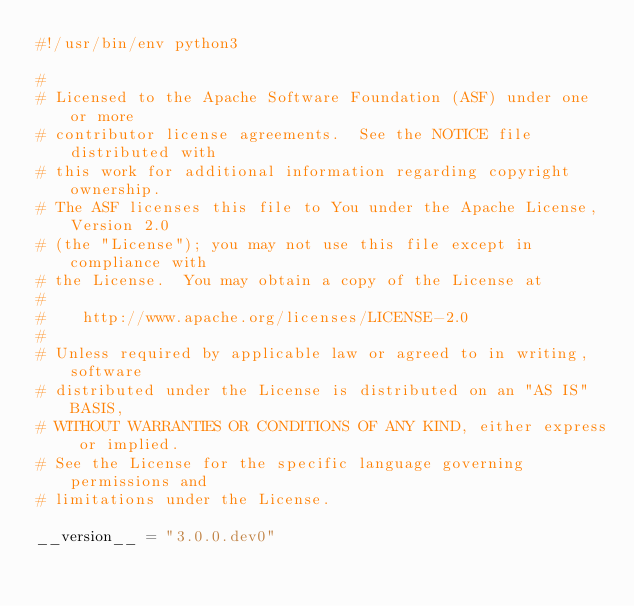<code> <loc_0><loc_0><loc_500><loc_500><_Python_>#!/usr/bin/env python3

#
# Licensed to the Apache Software Foundation (ASF) under one or more
# contributor license agreements.  See the NOTICE file distributed with
# this work for additional information regarding copyright ownership.
# The ASF licenses this file to You under the Apache License, Version 2.0
# (the "License"); you may not use this file except in compliance with
# the License.  You may obtain a copy of the License at
#
#    http://www.apache.org/licenses/LICENSE-2.0
#
# Unless required by applicable law or agreed to in writing, software
# distributed under the License is distributed on an "AS IS" BASIS,
# WITHOUT WARRANTIES OR CONDITIONS OF ANY KIND, either express or implied.
# See the License for the specific language governing permissions and
# limitations under the License.

__version__ = "3.0.0.dev0"
</code> 